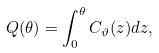Convert formula to latex. <formula><loc_0><loc_0><loc_500><loc_500>Q ( \theta ) = \int _ { 0 } ^ { \theta } C _ { \vartheta } ( z ) d z ,</formula> 